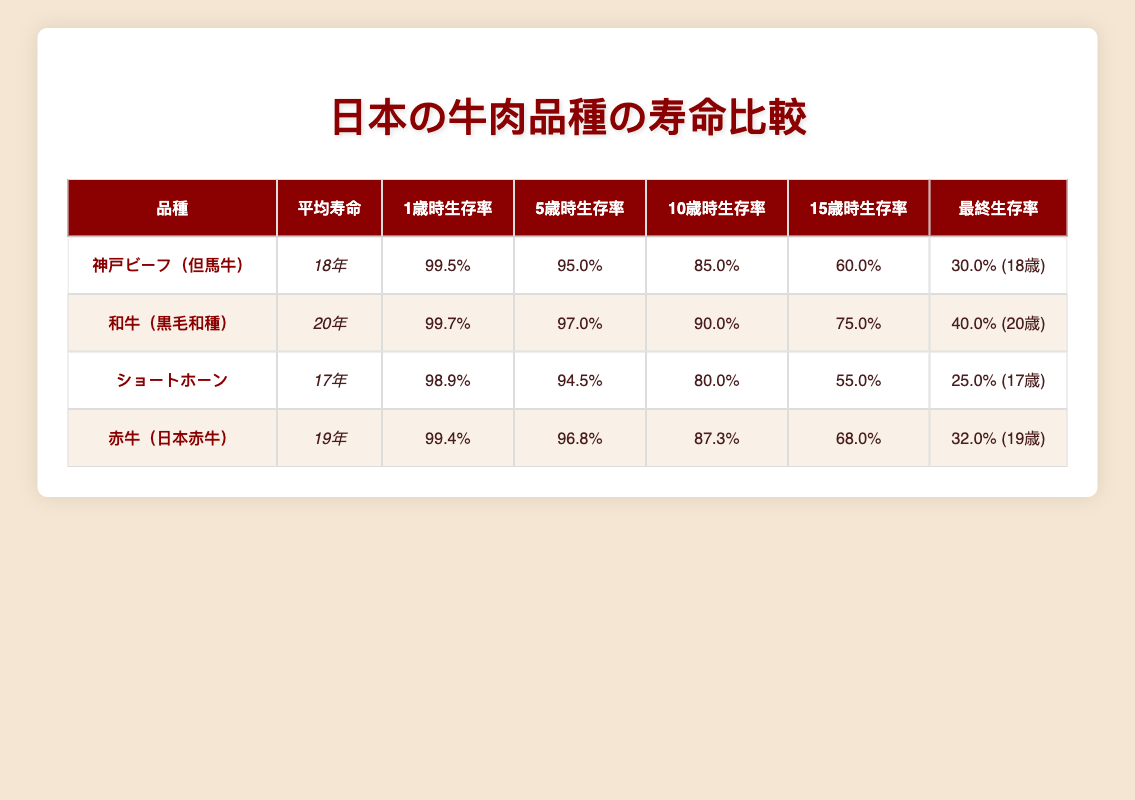What is the average life expectancy of Kobe Beef? The table shows that the average life expectancy of Kobe Beef (Tajima Cattle) is listed as 18 years.
Answer: 18 years Which breed has the highest survival rate at age 1? According to the survival rates at age 1, Wagyu (Japanese Black) has the highest survival rate at 99.7%.
Answer: Wagyu (Japanese Black) Is the average life expectancy of Shorthorn higher than that of Akaushi? The average life expectancy of Shorthorn is 17 years, while Akaushi is 19 years. Therefore, Shorthorn does not have a higher average life expectancy than Akaushi.
Answer: No What is the difference in average life expectancy between Wagyu and Shorthorn? The average life expectancy for Wagyu is 20 years and for Shorthorn, it is 17 years. Calculating the difference gives 20 - 17 = 3 years.
Answer: 3 years At what age does the survival rate drop below 40% for Wagyu? The survival rates for Wagyu show that it drops to 40% at age 20. Therefore, the age at which the survival rate is below 40% is 20 years and older.
Answer: 20 years Which breed has the lowest survival rate at age 15? Referring to the survival rates at age 15, Shorthorn shows the lowest survival rate at 55%.
Answer: Shorthorn What is the average life expectancy of the beef breeds listed in the table? The average life expectancy values are 18, 20, 17, and 19 years. Summing these gives 18 + 20 + 17 + 19 = 74. There are 4 breeds, so the average is 74 / 4 = 18.5 years.
Answer: 18.5 years Is it true that the survival rate of Akaushi at age 10 is higher than that of Kobe Beef? The survival rate at age 10 for Akaushi is 87.3% while for Kobe Beef it is 85.0%. Therefore, it is true that Akaushi has a higher survival rate at that age.
Answer: Yes What age has the highest survival rate for Shorthorn? Reviewing Shorthorn's survival rates, age 1 has the highest survival rate at 98.9%.
Answer: 1 year 